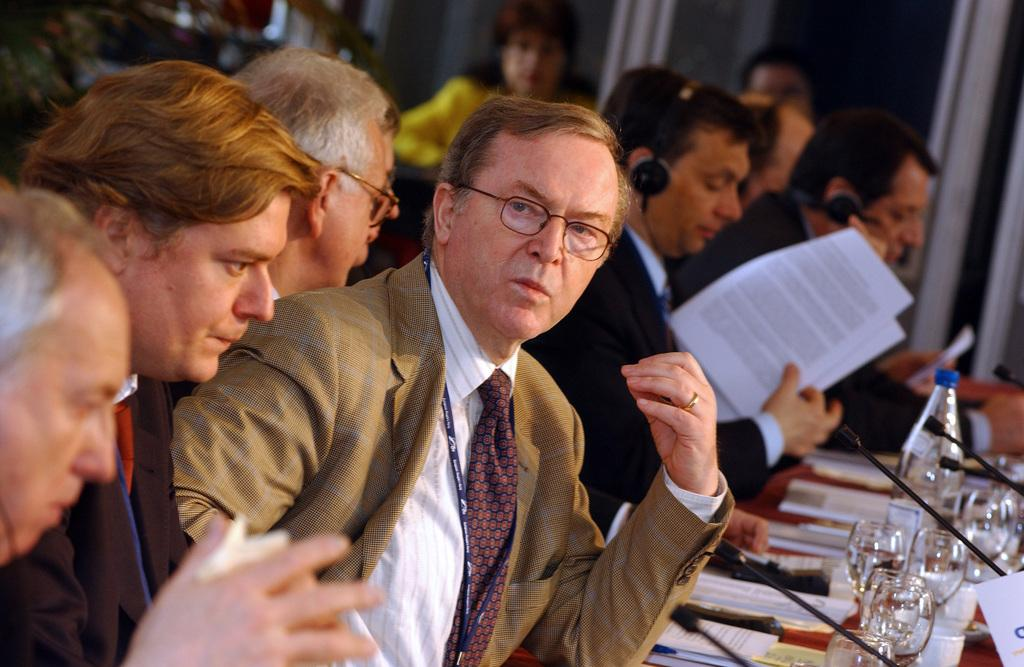What type of objects can be seen in the image? There are glasses, a bottle, microphones, and people wearing headsets in the image. What might the people be using the microphones for? The people might be using the microphones for recording or speaking into. What are the people holding in their hands? The people are holding objects in their hands, which could be related to their activities or tasks. What type of shade is present in the image? There is no shade present in the image; it does not mention any shading or covering. 